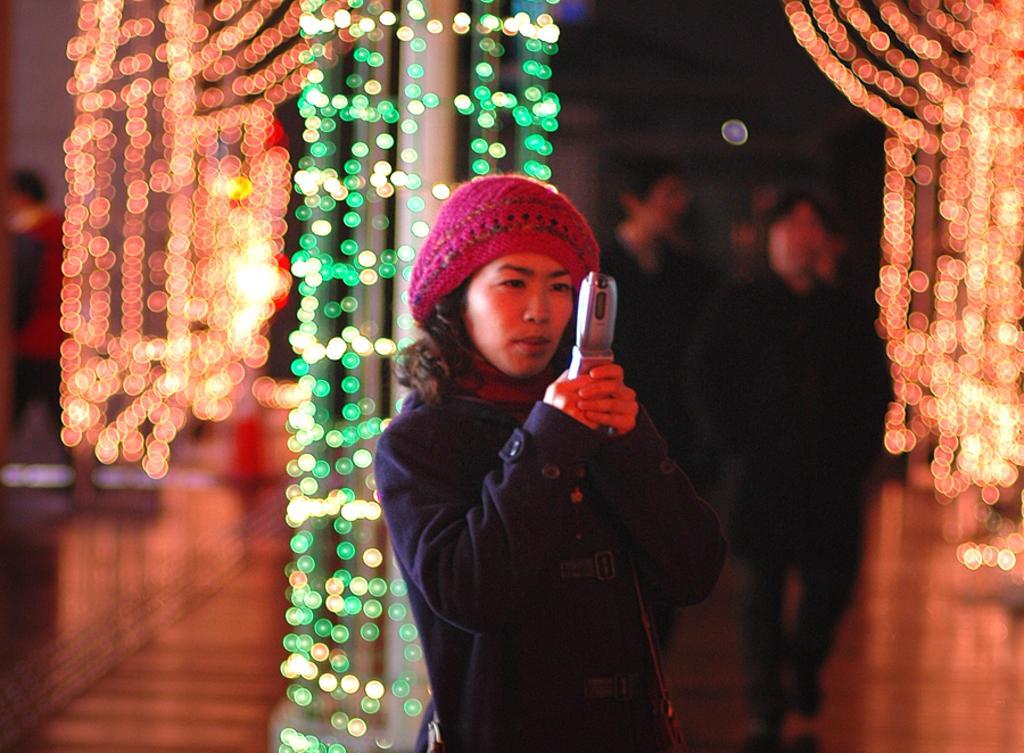Can you describe this image briefly? There is one woman standing and holding a mobile in the middle of this image, and we can see some other persons on the right side of this image. There are lights arranged in the background. 